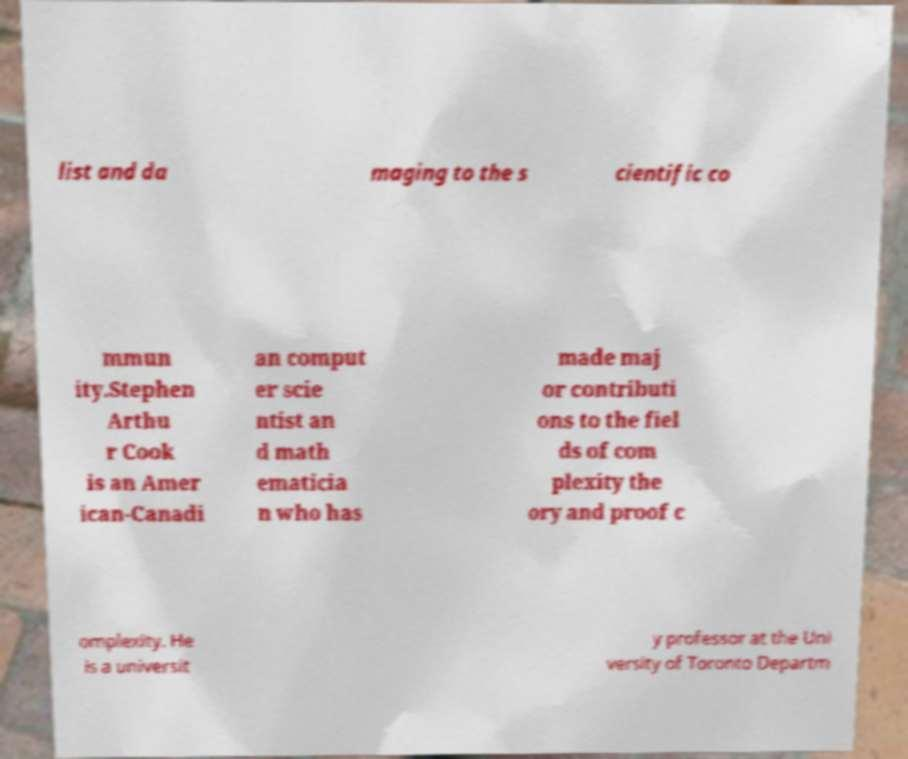I need the written content from this picture converted into text. Can you do that? list and da maging to the s cientific co mmun ity.Stephen Arthu r Cook is an Amer ican-Canadi an comput er scie ntist an d math ematicia n who has made maj or contributi ons to the fiel ds of com plexity the ory and proof c omplexity. He is a universit y professor at the Uni versity of Toronto Departm 